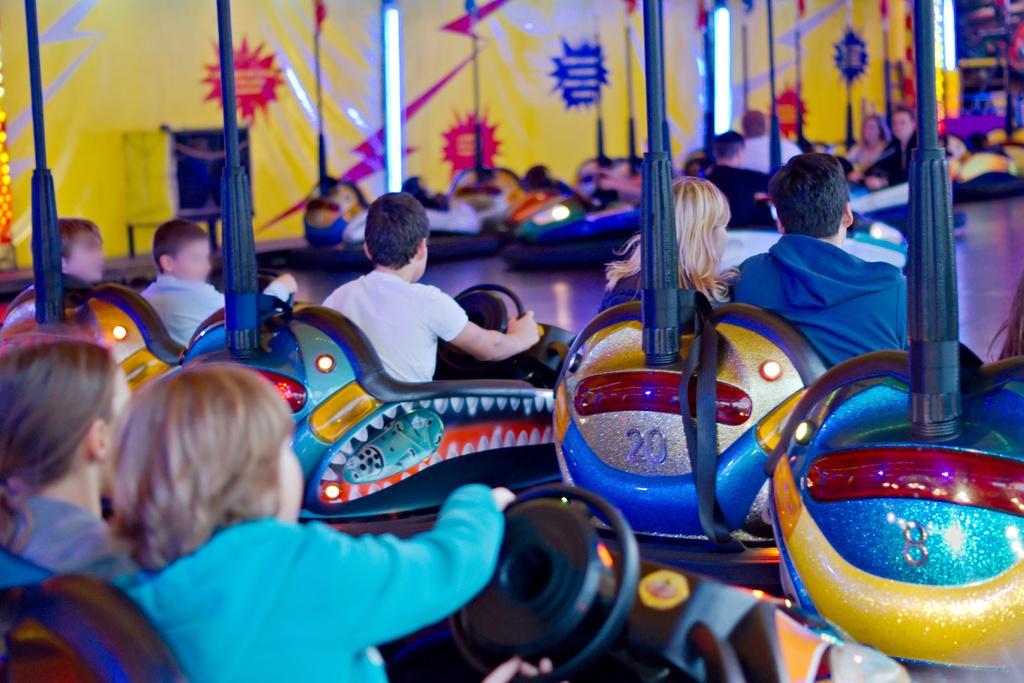Describe this image in one or two sentences. In the picture I can see people sitting in the dashing cars and playing. The background of the image is slightly blurred, where we can see a few more people sitting in the dashing cars, I can see lights and the yellow color wall. 